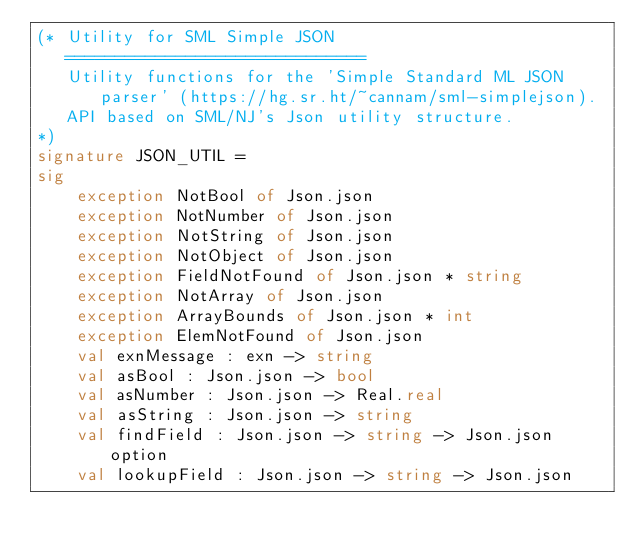Convert code to text. <code><loc_0><loc_0><loc_500><loc_500><_SML_>(* Utility for SML Simple JSON
   ==============================
   Utility functions for the 'Simple Standard ML JSON parser' (https://hg.sr.ht/~cannam/sml-simplejson).
   API based on SML/NJ's Json utility structure.
*)
signature JSON_UTIL =
sig
    exception NotBool of Json.json
    exception NotNumber of Json.json
    exception NotString of Json.json
    exception NotObject of Json.json
    exception FieldNotFound of Json.json * string
    exception NotArray of Json.json
    exception ArrayBounds of Json.json * int
    exception ElemNotFound of Json.json
    val exnMessage : exn -> string
    val asBool : Json.json -> bool
    val asNumber : Json.json -> Real.real
    val asString : Json.json -> string
    val findField : Json.json -> string -> Json.json option
    val lookupField : Json.json -> string -> Json.json</code> 